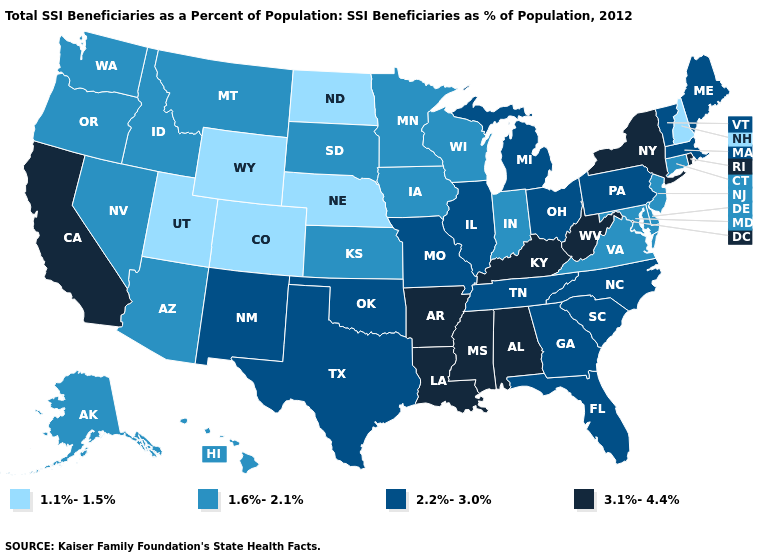Which states have the lowest value in the West?
Give a very brief answer. Colorado, Utah, Wyoming. What is the highest value in states that border Ohio?
Give a very brief answer. 3.1%-4.4%. What is the value of New Mexico?
Keep it brief. 2.2%-3.0%. Does Wyoming have the same value as Colorado?
Concise answer only. Yes. Does South Dakota have the highest value in the USA?
Short answer required. No. Among the states that border New Jersey , which have the lowest value?
Give a very brief answer. Delaware. What is the highest value in the USA?
Write a very short answer. 3.1%-4.4%. Name the states that have a value in the range 1.6%-2.1%?
Be succinct. Alaska, Arizona, Connecticut, Delaware, Hawaii, Idaho, Indiana, Iowa, Kansas, Maryland, Minnesota, Montana, Nevada, New Jersey, Oregon, South Dakota, Virginia, Washington, Wisconsin. Is the legend a continuous bar?
Give a very brief answer. No. What is the value of Indiana?
Short answer required. 1.6%-2.1%. Does Indiana have the same value as Alaska?
Give a very brief answer. Yes. What is the value of Arkansas?
Keep it brief. 3.1%-4.4%. What is the lowest value in the MidWest?
Answer briefly. 1.1%-1.5%. Name the states that have a value in the range 1.6%-2.1%?
Answer briefly. Alaska, Arizona, Connecticut, Delaware, Hawaii, Idaho, Indiana, Iowa, Kansas, Maryland, Minnesota, Montana, Nevada, New Jersey, Oregon, South Dakota, Virginia, Washington, Wisconsin. Does Wyoming have the lowest value in the USA?
Concise answer only. Yes. 